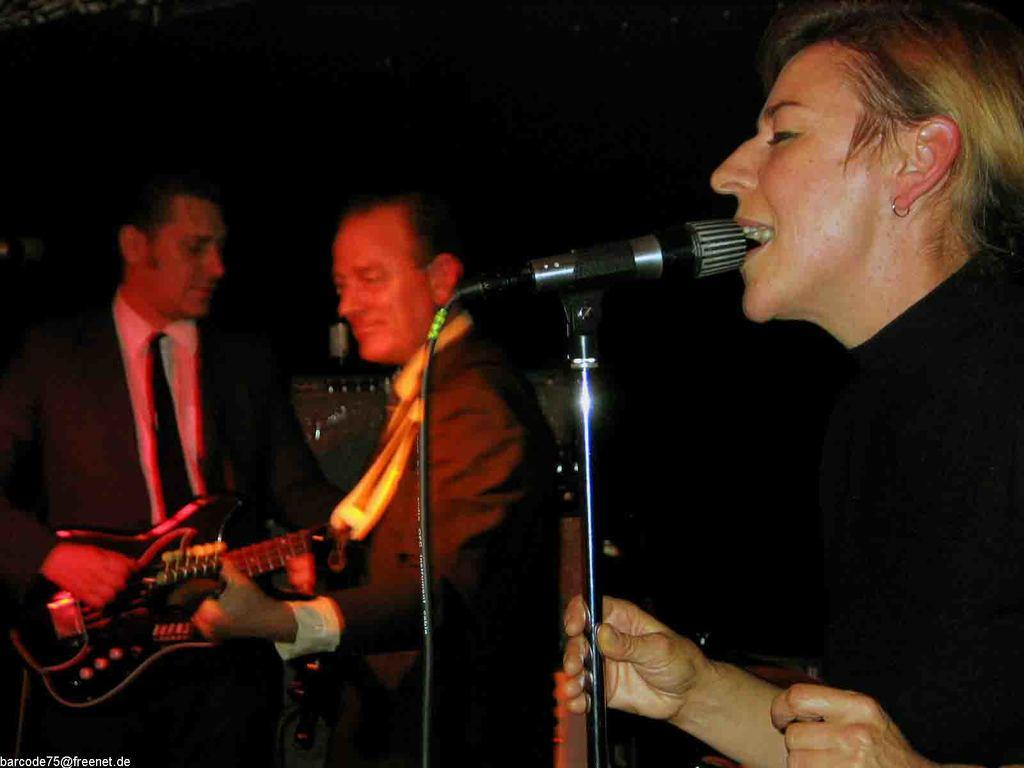What is the main activity of the person in the image? The person in the image is singing. What is the person holding while singing? The person is holding a microphone. What are the other two persons in the image doing? The two other persons are playing guitars. What type of spark can be seen coming from the garden in the image? There is no garden or spark present in the image. 